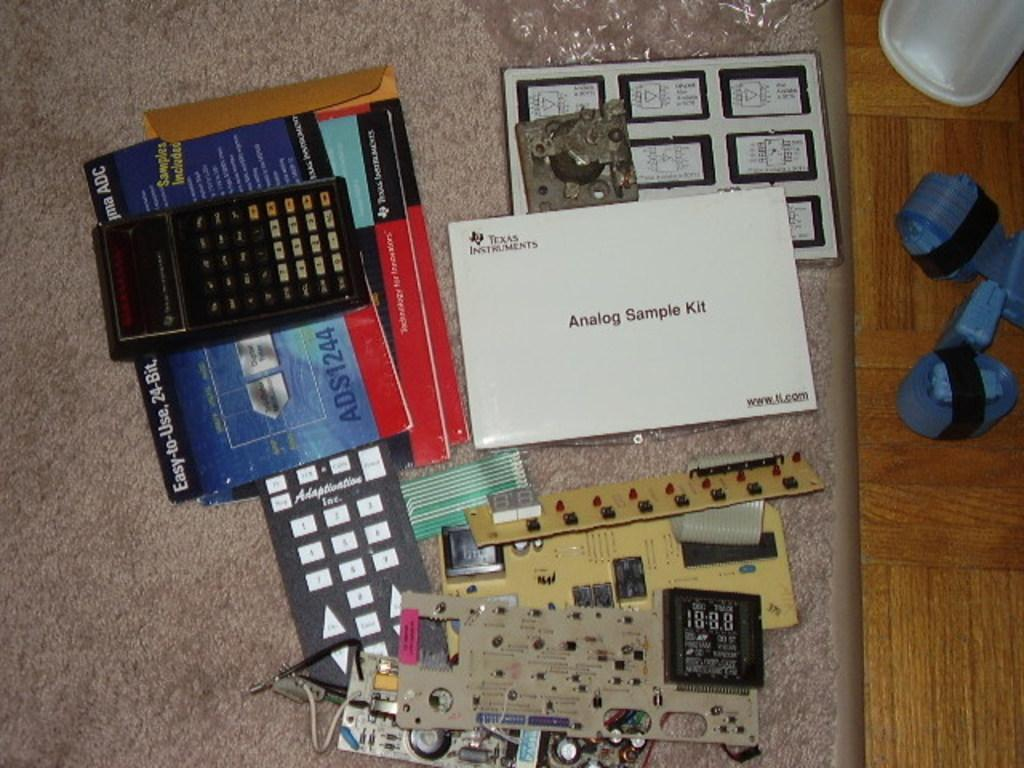<image>
Offer a succinct explanation of the picture presented. A white Texas Instrument Analog Sample Kit sits on a carpet with several calculators and electronic elements 